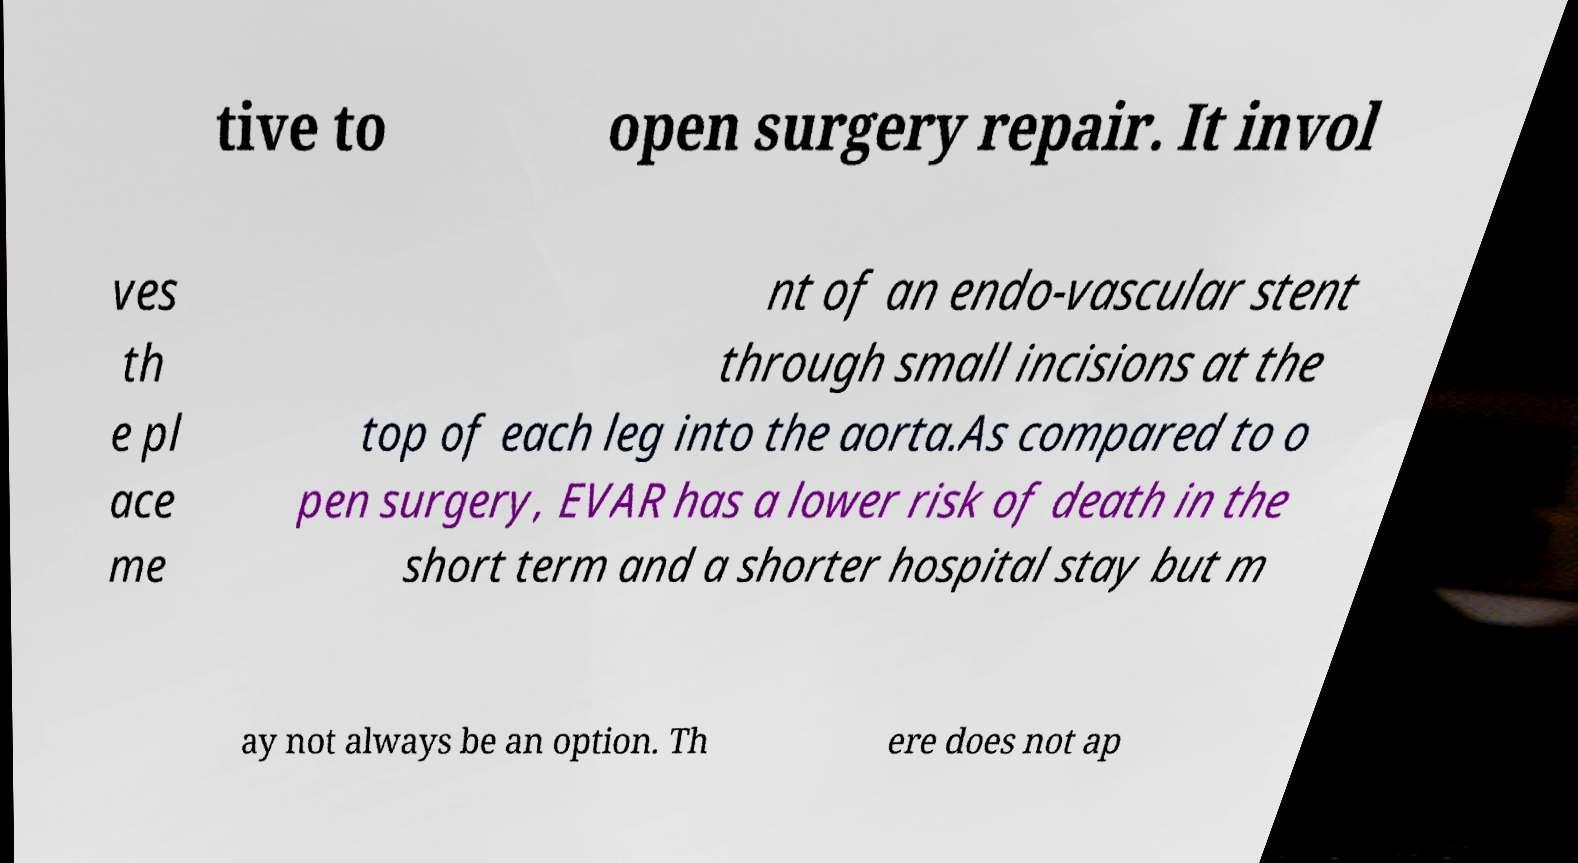What messages or text are displayed in this image? I need them in a readable, typed format. tive to open surgery repair. It invol ves th e pl ace me nt of an endo-vascular stent through small incisions at the top of each leg into the aorta.As compared to o pen surgery, EVAR has a lower risk of death in the short term and a shorter hospital stay but m ay not always be an option. Th ere does not ap 